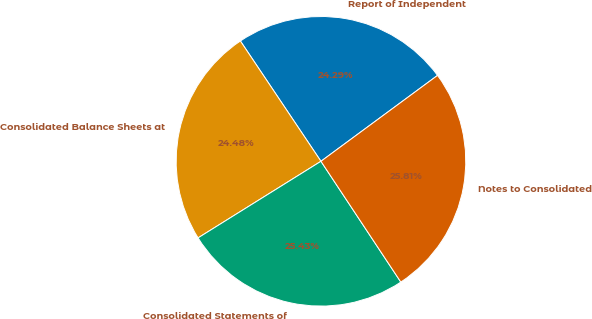Convert chart. <chart><loc_0><loc_0><loc_500><loc_500><pie_chart><fcel>Report of Independent<fcel>Consolidated Balance Sheets at<fcel>Consolidated Statements of<fcel>Notes to Consolidated<nl><fcel>24.29%<fcel>24.48%<fcel>25.43%<fcel>25.81%<nl></chart> 